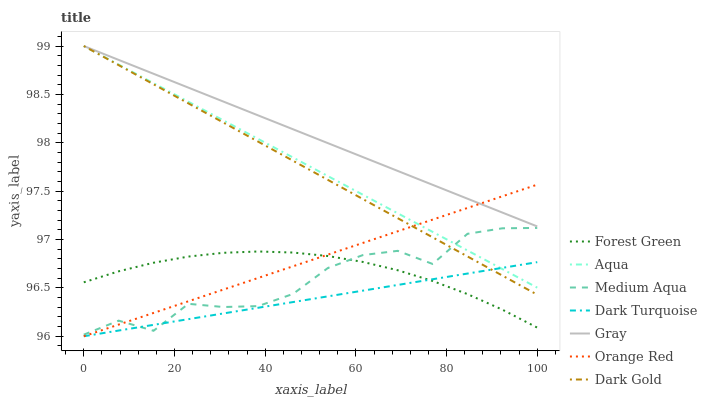Does Dark Turquoise have the minimum area under the curve?
Answer yes or no. Yes. Does Gray have the maximum area under the curve?
Answer yes or no. Yes. Does Dark Gold have the minimum area under the curve?
Answer yes or no. No. Does Dark Gold have the maximum area under the curve?
Answer yes or no. No. Is Orange Red the smoothest?
Answer yes or no. Yes. Is Medium Aqua the roughest?
Answer yes or no. Yes. Is Dark Gold the smoothest?
Answer yes or no. No. Is Dark Gold the roughest?
Answer yes or no. No. Does Dark Turquoise have the lowest value?
Answer yes or no. Yes. Does Dark Gold have the lowest value?
Answer yes or no. No. Does Aqua have the highest value?
Answer yes or no. Yes. Does Dark Turquoise have the highest value?
Answer yes or no. No. Is Dark Turquoise less than Gray?
Answer yes or no. Yes. Is Dark Gold greater than Forest Green?
Answer yes or no. Yes. Does Gray intersect Aqua?
Answer yes or no. Yes. Is Gray less than Aqua?
Answer yes or no. No. Is Gray greater than Aqua?
Answer yes or no. No. Does Dark Turquoise intersect Gray?
Answer yes or no. No. 